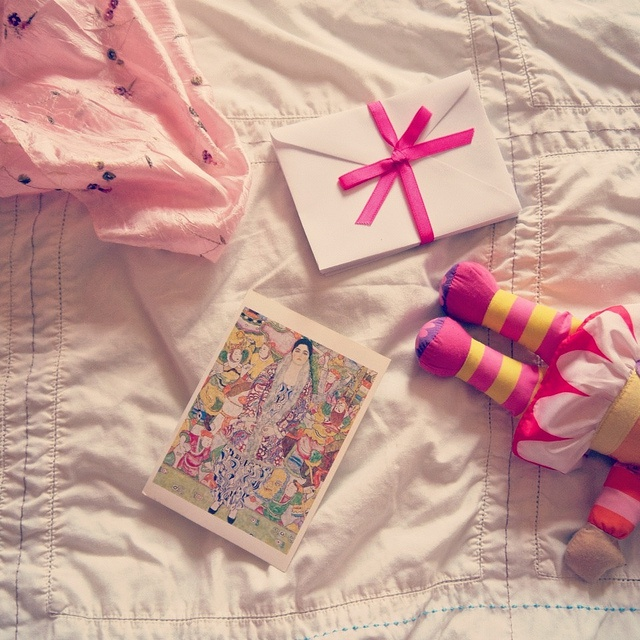Describe the objects in this image and their specific colors. I can see a bed in tan, brown, gray, and darkgray tones in this image. 